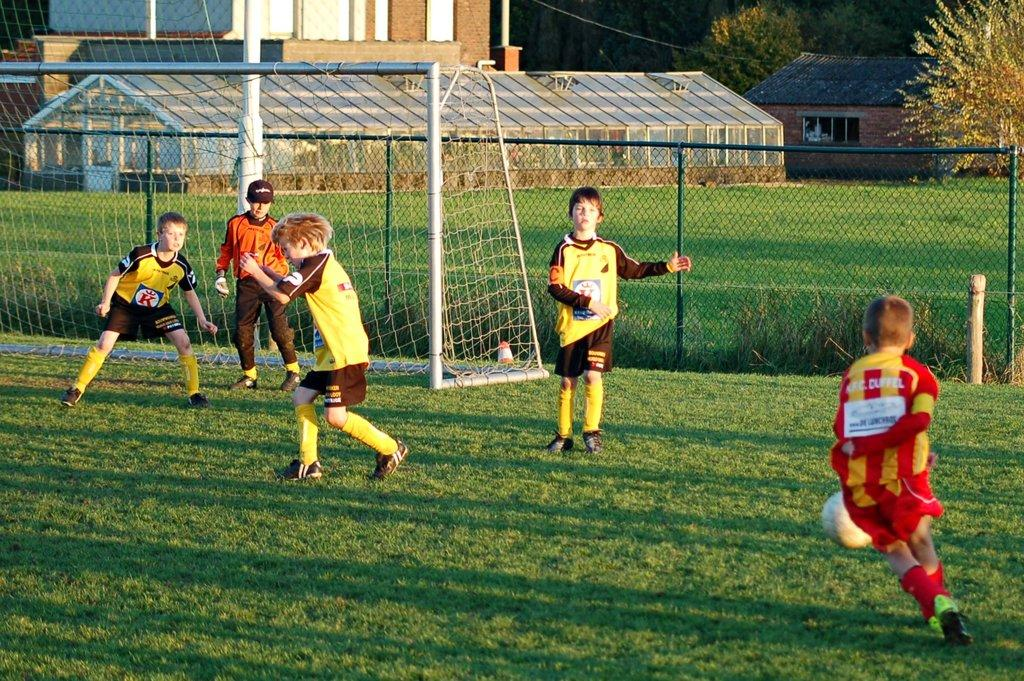<image>
Write a terse but informative summary of the picture. The yellow team with a K on their jerseys is going against a red team in a soccer game. 